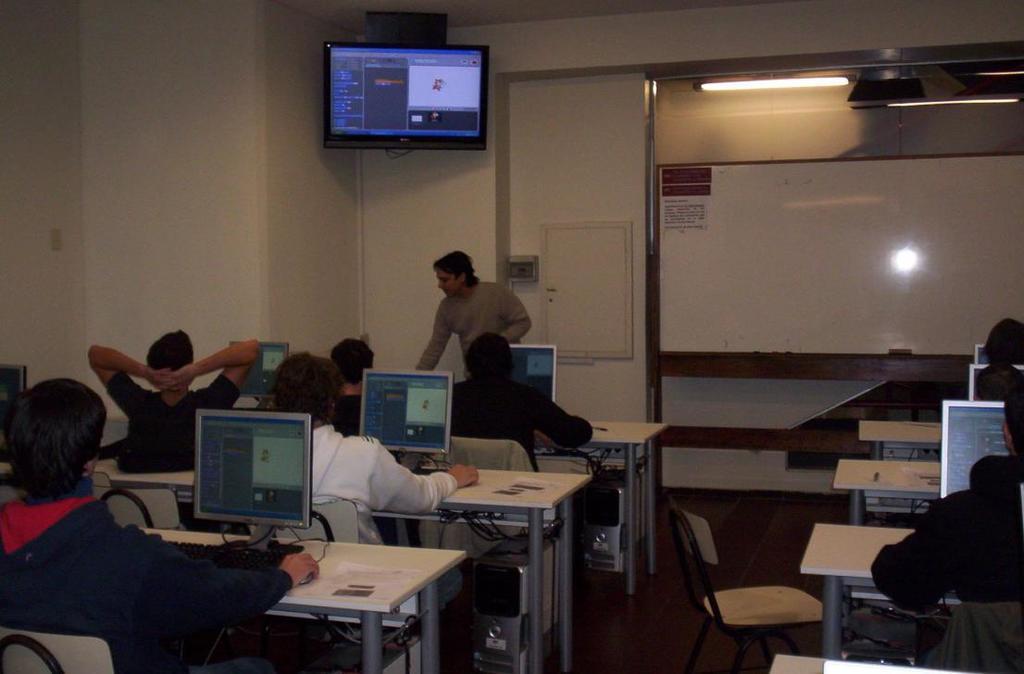In one or two sentences, can you explain what this image depicts? In this image we can see this people are sitting on the chairs near the table. There are monitors placed on the table. In the background we can see a man standing, board and lights. 